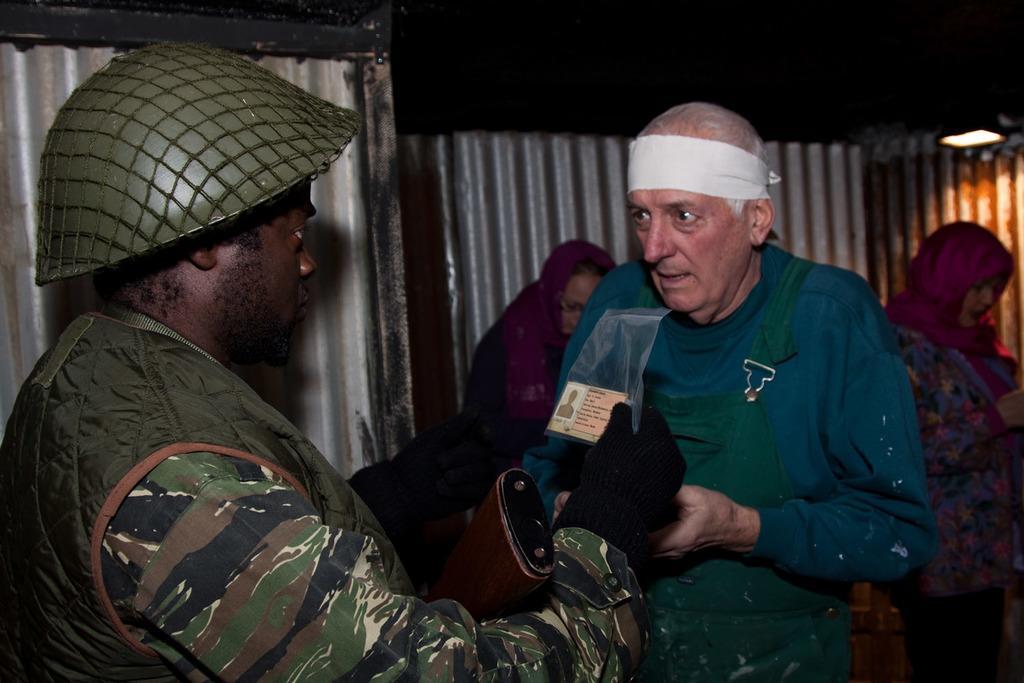In one or two sentences, can you explain what this image depicts? In this image I can see a person wearing uniform is standing and holding a paper in his hand. I can see another person wearing green colored dress is standing in front of him. I can see few persons standing, a light, few metal sheets and the dark sky in the background. 